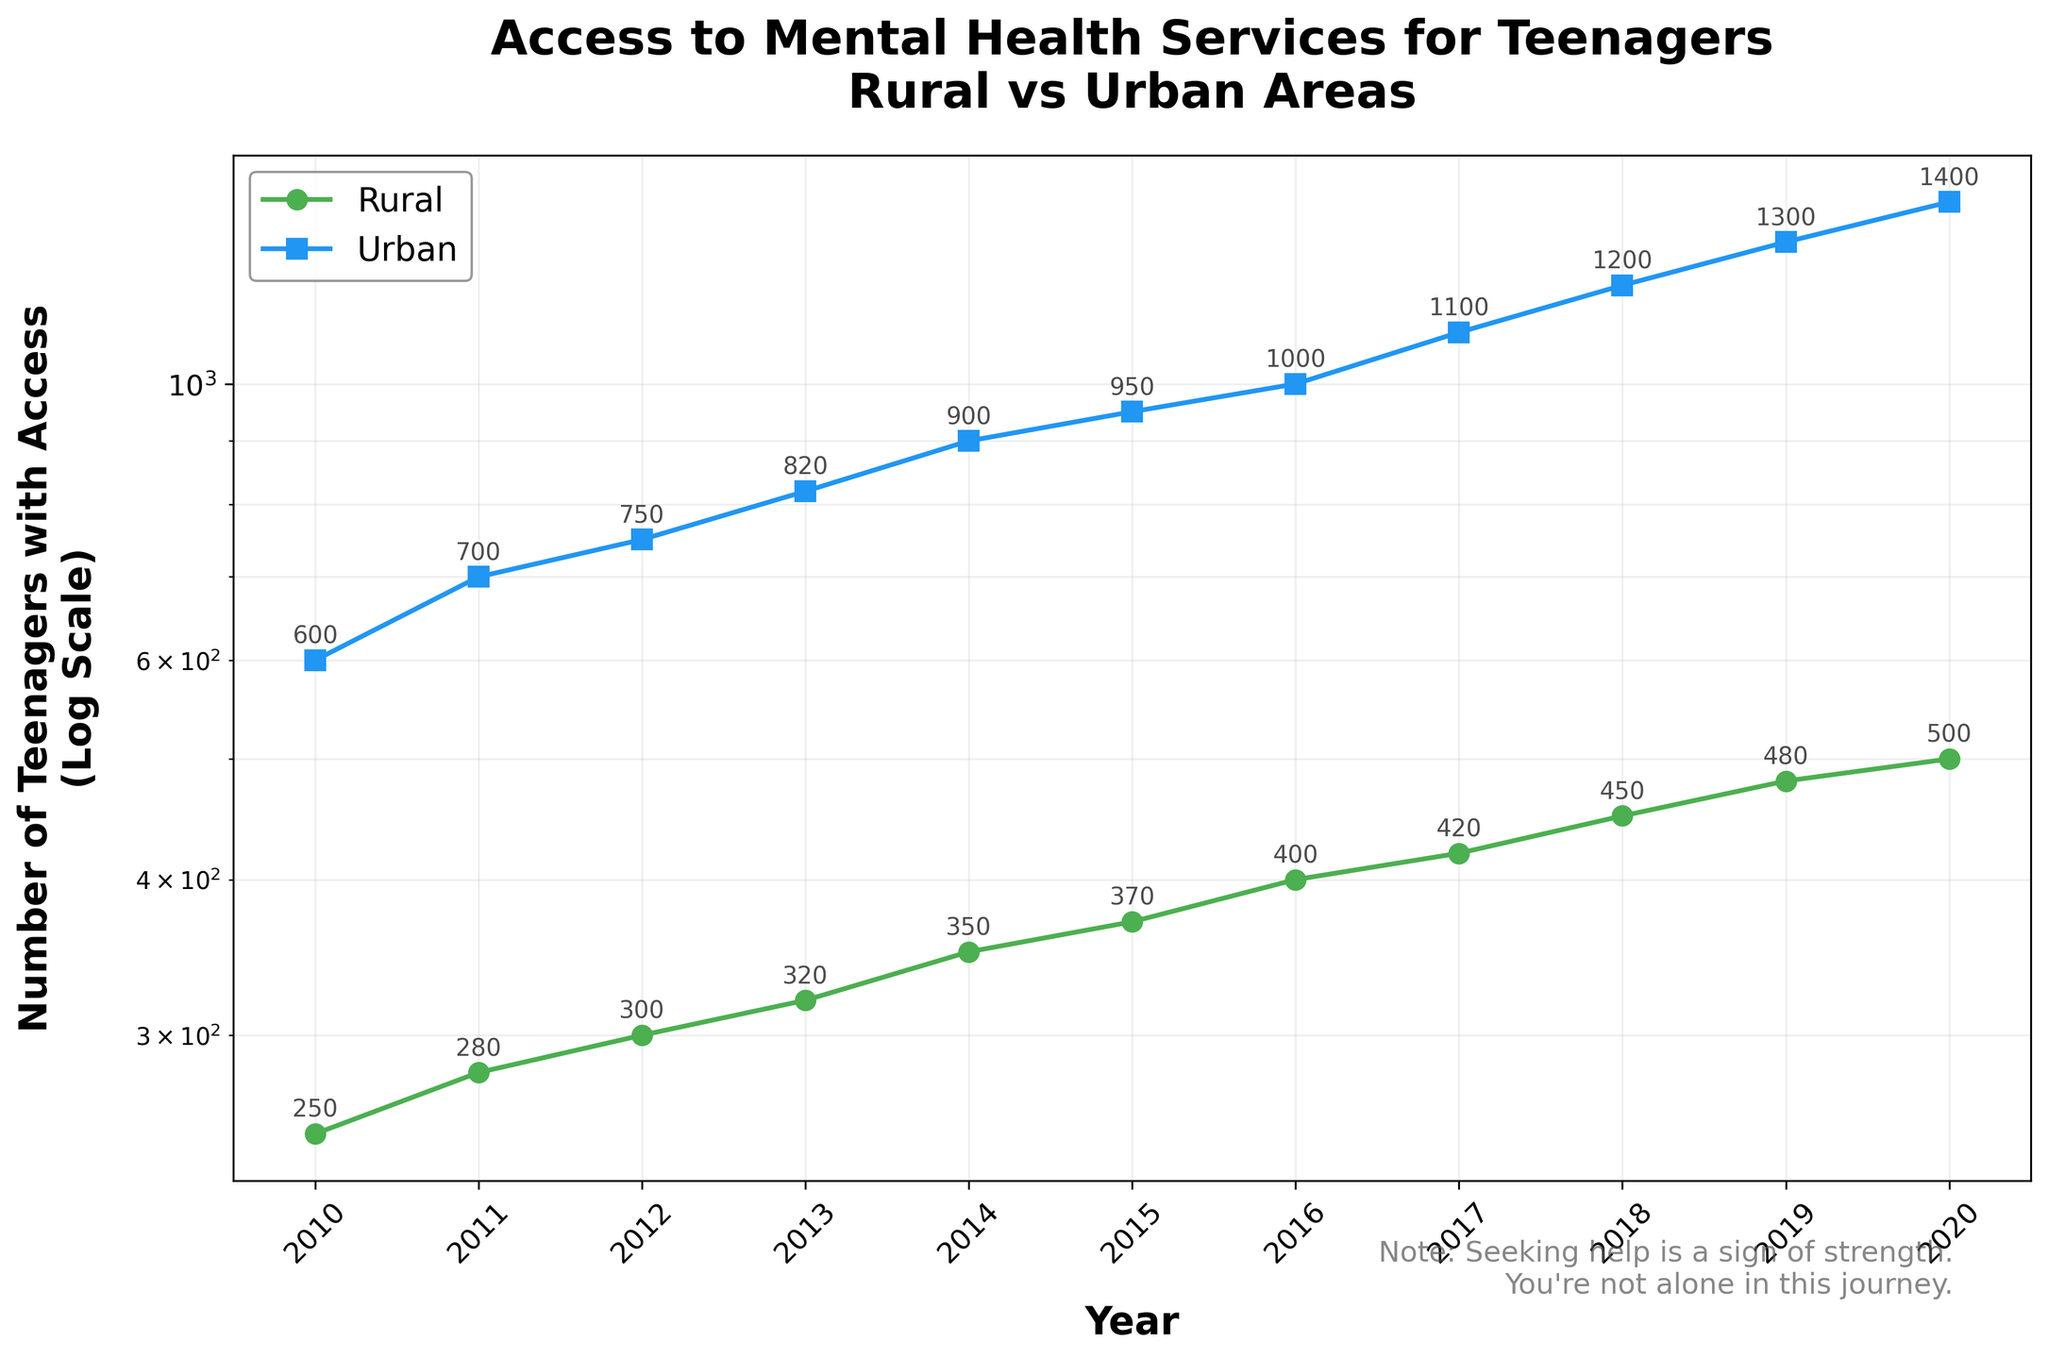How many data points are there in total? The figure contains data points for each year from 2010 to 2020 for both rural and urban areas. That's 11 years x 2 regions = 22 data points.
Answer: 22 What is the title of the figure? The title is located at the top of the figure and it reads 'Access to Mental Health Services for Teenagers\nRural vs Urban Areas'.
Answer: Access to Mental Health Services for Teenagers\nRural vs Urban Areas What colors are used to represent rural and urban areas? The color of the lines and markers representing rural areas is green, and for urban areas, it is blue.
Answer: Green for rural, Blue for urban Which year had the highest number of teenagers with access to mental health services in urban areas? By looking at the highest data point in the blue line on the figure, the year 2020 has 1400 teenagers with access, which is the highest.
Answer: 2020 How many teenagers had access to mental health services in rural areas in 2010 and 2015 combined? Add the number of teenagers from rural areas for the years 2010 (250) and 2015 (370). 250 + 370 = 620
Answer: 620 How does the number of teenagers with access to mental health services in urban areas change from 2010 to 2020? The blue line gradually increases from 600 in 2010 to 1400 in 2020, representing a consistent upward trend in urban areas.
Answer: It increases What is the difference in access to mental health services between rural and urban areas in 2018? In 2018, urban areas had 1200, and rural areas had 450. The difference is 1200 - 450 = 750.
Answer: 750 In which year did rural areas see the greatest improvement in access to mental health services compared to the previous year? By looking for the largest year-to-year increase in the green line, the period from 2018 (450) to 2019 (480) shows the largest improvement (30 teenagers).
Answer: 2019 How does access to mental health services in rural areas change from 2010 to 2020 on a log scale? Observing the green line on the log scale, there's a steady increase in the number of teenagers with access to services, indicating consistent growth, even though the actual numbers remain lower compared to urban areas.
Answer: Steady increase Compare the general trend of access to mental health services in rural versus urban areas. Both areas show an increasing trend over the years, but the urban area starts higher and increases more rapidly compared to the rural area, which starts lower and increases more gradually.
Answer: Urban areas have a steeper increase 